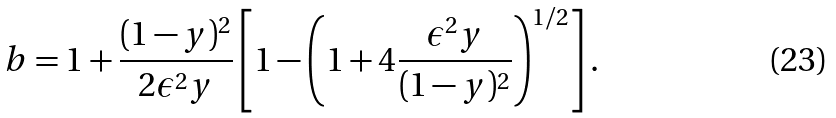<formula> <loc_0><loc_0><loc_500><loc_500>b = 1 + \frac { ( 1 - y ) ^ { 2 } } { 2 \epsilon ^ { 2 } y } \left [ 1 - \left ( 1 + 4 \frac { \epsilon ^ { 2 } y } { ( 1 - y ) ^ { 2 } } \right ) ^ { 1 / 2 } \right ] .</formula> 